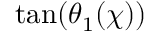Convert formula to latex. <formula><loc_0><loc_0><loc_500><loc_500>\tan ( \theta _ { 1 } ( \chi ) )</formula> 